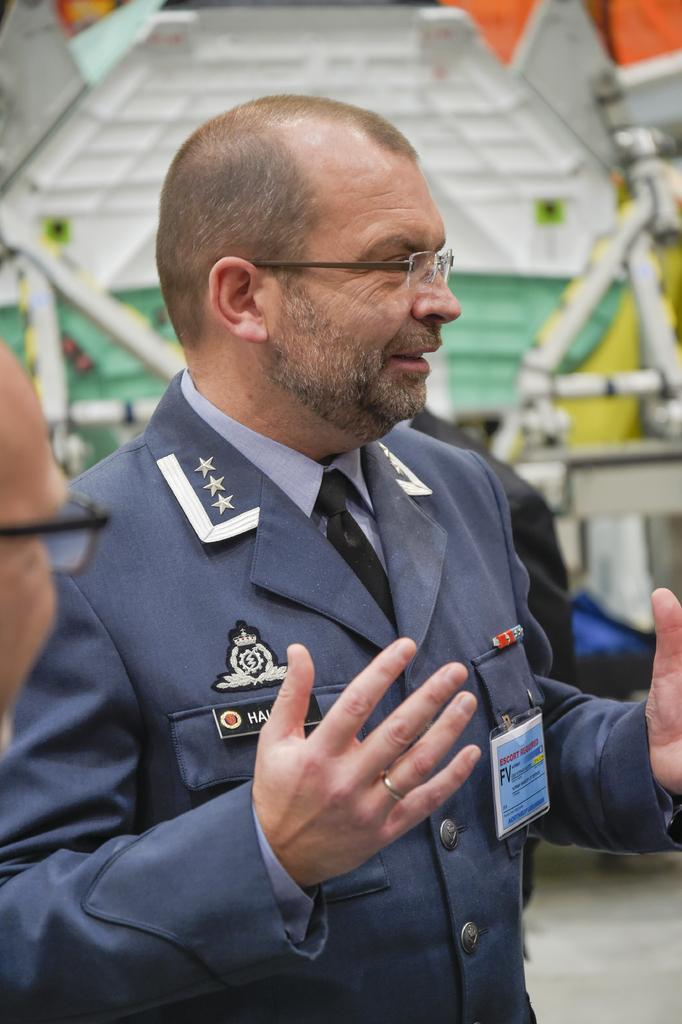How many people are in the image? There are three persons standing in the image. Can you describe the appearance of one of the persons? One person is wearing spectacles and a coat. What items can be seen on the person with spectacles? The person with spectacles has an id card with text on it and a badge. What can be seen in the background of the image? There are poles visible in the background of the image. What time of day is it in the image? The provided facts do not give any information about the time of day, so it cannot be determined from the image. Is this a school setting? There is no information in the image to suggest that it is a school setting. 